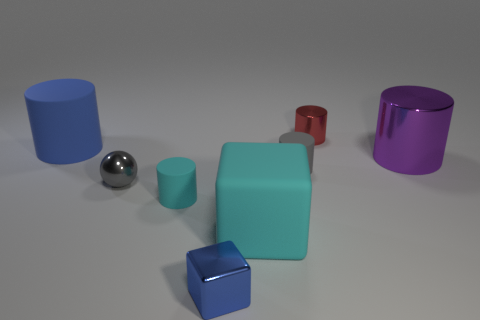Subtract 3 cylinders. How many cylinders are left? 2 Subtract all red cylinders. How many cylinders are left? 4 Subtract all gray cylinders. How many cylinders are left? 4 Add 1 big cyan rubber blocks. How many objects exist? 9 Subtract all blue cylinders. Subtract all red balls. How many cylinders are left? 4 Add 5 small gray balls. How many small gray balls exist? 6 Subtract 1 gray spheres. How many objects are left? 7 Subtract all blocks. How many objects are left? 6 Subtract all tiny green matte spheres. Subtract all purple shiny objects. How many objects are left? 7 Add 1 gray cylinders. How many gray cylinders are left? 2 